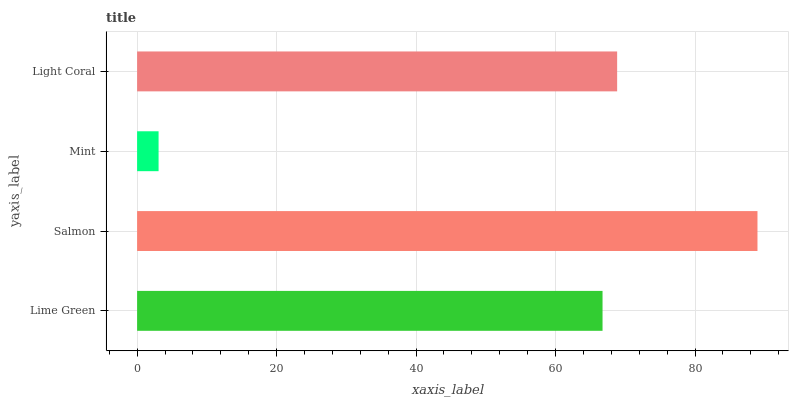Is Mint the minimum?
Answer yes or no. Yes. Is Salmon the maximum?
Answer yes or no. Yes. Is Salmon the minimum?
Answer yes or no. No. Is Mint the maximum?
Answer yes or no. No. Is Salmon greater than Mint?
Answer yes or no. Yes. Is Mint less than Salmon?
Answer yes or no. Yes. Is Mint greater than Salmon?
Answer yes or no. No. Is Salmon less than Mint?
Answer yes or no. No. Is Light Coral the high median?
Answer yes or no. Yes. Is Lime Green the low median?
Answer yes or no. Yes. Is Salmon the high median?
Answer yes or no. No. Is Light Coral the low median?
Answer yes or no. No. 